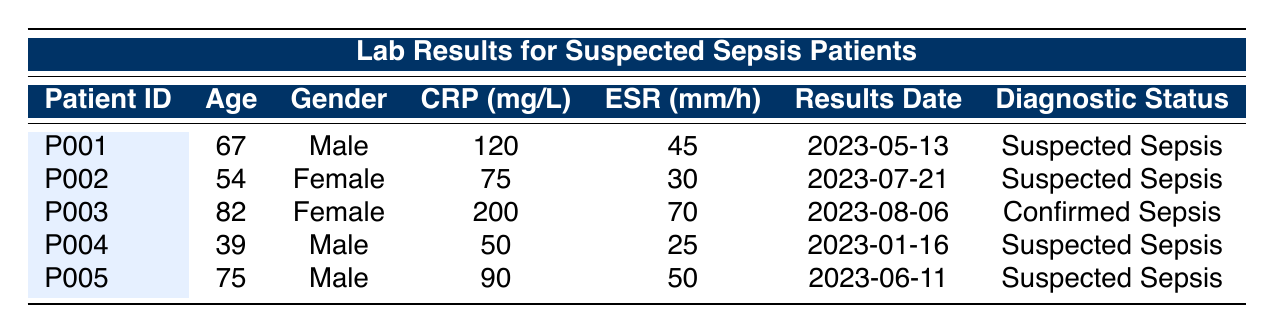What is the highest CRP level recorded in the table? The highest CRP level can be found by looking at the CRP values across all patients. Patient P003 has a CRP level of 200 mg/L, which is greater than all other recorded levels (120, 75, 50, and 90 mg/L).
Answer: 200 mg/L How many patients in the table are diagnosed with suspected sepsis? The diagnostic status column shows that patients P001, P002, P004, and P005 are diagnosed with suspected sepsis. Counting these entries gives a total of four patients.
Answer: 4 What is the average ESR level among all patients? To find the average ESR, sum the ESR levels (45 + 30 + 70 + 25 + 50 = 220) and divide by the number of patients (5). The calculation results in an average ESR of 220/5 = 44 mm/h.
Answer: 44 mm/h Does any patient have an ESR less than 30 mm/h? By examining the ESR values in the table, only one patient, P002, has an ESR of 30 mm/h, which is not less than 30. Therefore, no patient meets the criteria.
Answer: No Which patient's results have the lowest CRP level, and what is that level? The lowest CRP level is found by comparing all CRP values. P004 has a CRP level of 50 mg/L, which is less than the other levels (200, 120, 75, and 90 mg/L). Thus, the patient with the lowest CRP level is P004 with 50 mg/L.
Answer: P004, 50 mg/L How many male patients have been diagnosed with suspected sepsis? By looking through the patients listed, P001, P004, and P005 are male and have suspected sepsis status. Counting these gives a total of three male patients.
Answer: 3 What is the relationship between age and CRP levels among the patients? To assess the relationship, we observe the ages and their corresponding CRP levels. Patient ages and CRP levels are: P001 (67, 120), P002 (54, 75), P003 (82, 200), P004 (39, 50), and P005 (75, 90). Older patients like P003 (82) tend to have higher CRP levels. Thus, higher CRP levels are associated with older age.
Answer: Higher age correlates with higher CRP levels Is there a confirmed sepsis case listed in the data? The table shows that Patient P003 has a diagnostic status of confirmed sepsis. Therefore, yes, there is at least one confirmed sepsis case in the data.
Answer: Yes What is the difference in CRP levels between the oldest and youngest patients? The oldest patient is P003 with a CRP of 200 mg/L and the youngest patient is P004 with a CRP of 50 mg/L. The difference in their CRP levels is calculated as 200 - 50 = 150 mg/L.
Answer: 150 mg/L 